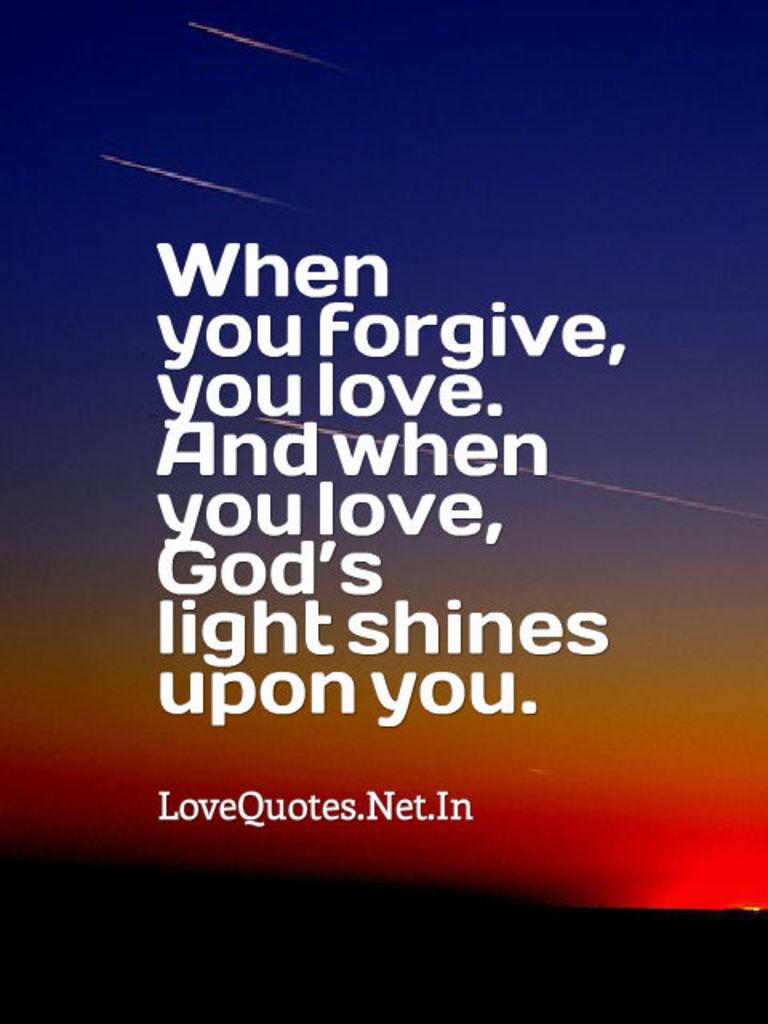Whos light shines upon you?
Provide a succinct answer. God's. What is the url for the quotes?
Keep it short and to the point. Lovequotes.net.in. 